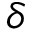Convert formula to latex. <formula><loc_0><loc_0><loc_500><loc_500>\delta</formula> 